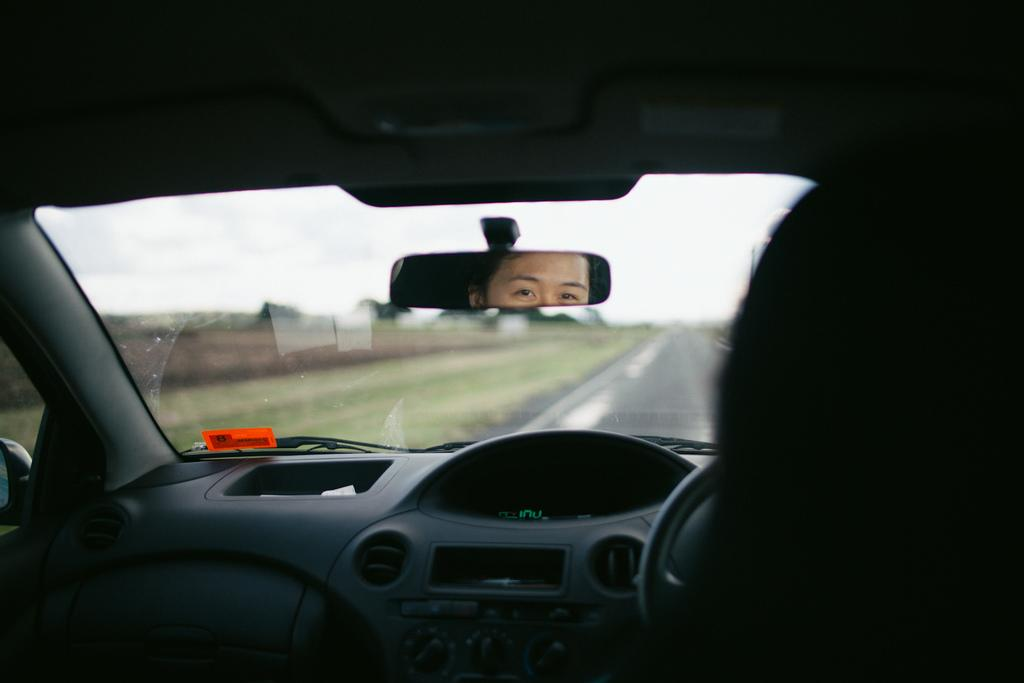What type of location is shown in the image? The image is an inside view of a car. Can you describe what is visible in the mirror? There is a person visible in the mirror. What can be seen outside the car in the image? There is a road visible in the image. What type of school can be seen in the image? There is no school visible in the image; it is an inside view of a car. What reason might the person in the mirror have for being in the car? The image does not provide any information about the person's reason for being in the car, so we cannot determine their reason from the image. 